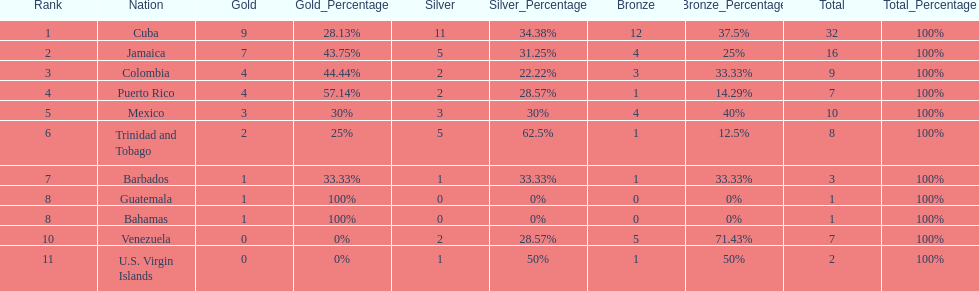Who had more silvers? colmbia or the bahamas Colombia. 